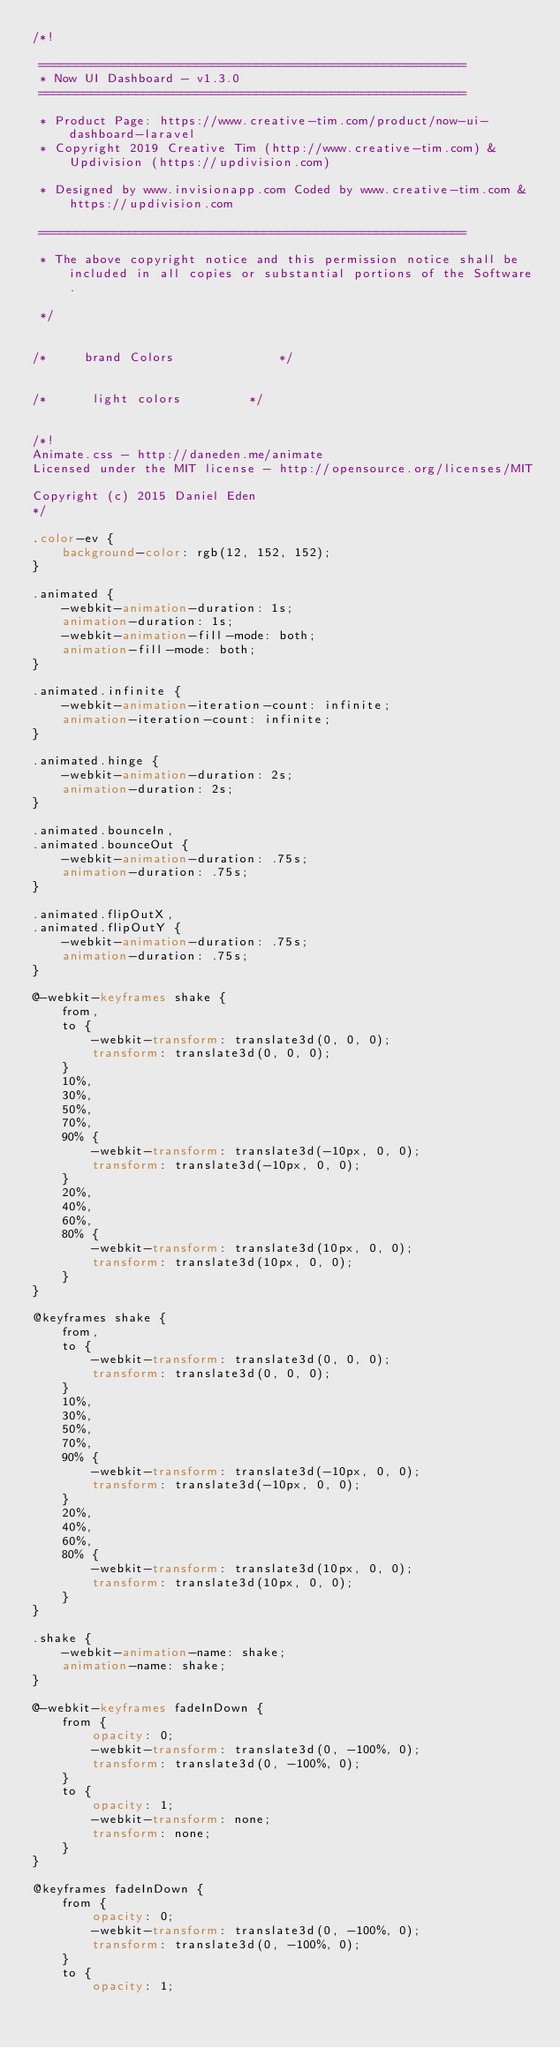Convert code to text. <code><loc_0><loc_0><loc_500><loc_500><_CSS_>/*!

 =========================================================
 * Now UI Dashboard - v1.3.0
 =========================================================

 * Product Page: https://www.creative-tim.com/product/now-ui-dashboard-laravel
 * Copyright 2019 Creative Tim (http://www.creative-tim.com) & Updivision (https://updivision.com)

 * Designed by www.invisionapp.com Coded by www.creative-tim.com & https://updivision.com

 =========================================================

 * The above copyright notice and this permission notice shall be included in all copies or substantial portions of the Software.

 */


/*     brand Colors              */


/*      light colors         */


/*!
Animate.css - http://daneden.me/animate
Licensed under the MIT license - http://opensource.org/licenses/MIT

Copyright (c) 2015 Daniel Eden
*/

.color-ev {
    background-color: rgb(12, 152, 152);
}

.animated {
    -webkit-animation-duration: 1s;
    animation-duration: 1s;
    -webkit-animation-fill-mode: both;
    animation-fill-mode: both;
}

.animated.infinite {
    -webkit-animation-iteration-count: infinite;
    animation-iteration-count: infinite;
}

.animated.hinge {
    -webkit-animation-duration: 2s;
    animation-duration: 2s;
}

.animated.bounceIn,
.animated.bounceOut {
    -webkit-animation-duration: .75s;
    animation-duration: .75s;
}

.animated.flipOutX,
.animated.flipOutY {
    -webkit-animation-duration: .75s;
    animation-duration: .75s;
}

@-webkit-keyframes shake {
    from,
    to {
        -webkit-transform: translate3d(0, 0, 0);
        transform: translate3d(0, 0, 0);
    }
    10%,
    30%,
    50%,
    70%,
    90% {
        -webkit-transform: translate3d(-10px, 0, 0);
        transform: translate3d(-10px, 0, 0);
    }
    20%,
    40%,
    60%,
    80% {
        -webkit-transform: translate3d(10px, 0, 0);
        transform: translate3d(10px, 0, 0);
    }
}

@keyframes shake {
    from,
    to {
        -webkit-transform: translate3d(0, 0, 0);
        transform: translate3d(0, 0, 0);
    }
    10%,
    30%,
    50%,
    70%,
    90% {
        -webkit-transform: translate3d(-10px, 0, 0);
        transform: translate3d(-10px, 0, 0);
    }
    20%,
    40%,
    60%,
    80% {
        -webkit-transform: translate3d(10px, 0, 0);
        transform: translate3d(10px, 0, 0);
    }
}

.shake {
    -webkit-animation-name: shake;
    animation-name: shake;
}

@-webkit-keyframes fadeInDown {
    from {
        opacity: 0;
        -webkit-transform: translate3d(0, -100%, 0);
        transform: translate3d(0, -100%, 0);
    }
    to {
        opacity: 1;
        -webkit-transform: none;
        transform: none;
    }
}

@keyframes fadeInDown {
    from {
        opacity: 0;
        -webkit-transform: translate3d(0, -100%, 0);
        transform: translate3d(0, -100%, 0);
    }
    to {
        opacity: 1;</code> 